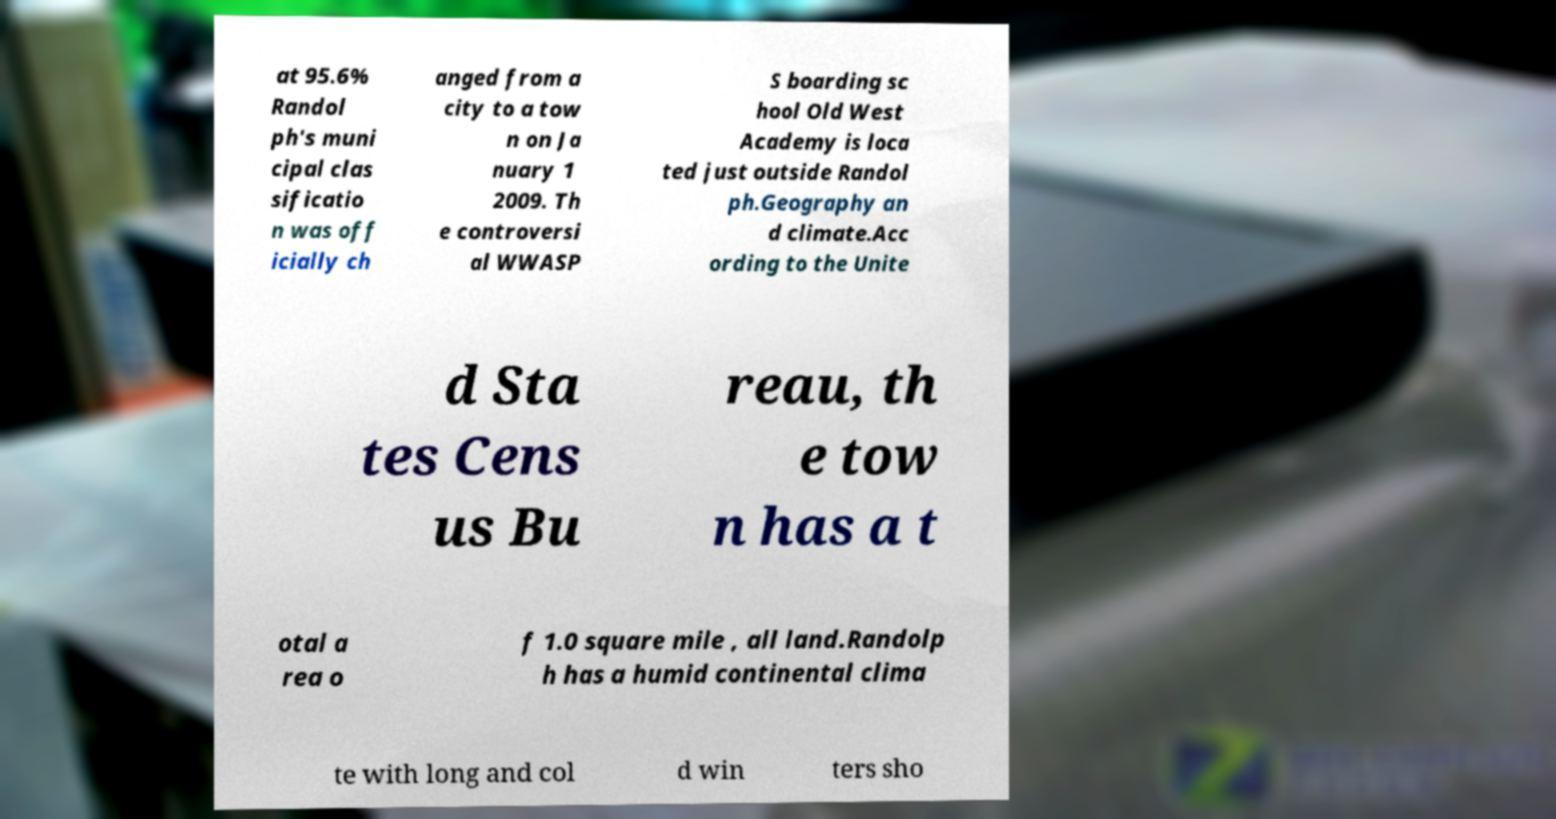I need the written content from this picture converted into text. Can you do that? at 95.6% Randol ph's muni cipal clas sificatio n was off icially ch anged from a city to a tow n on Ja nuary 1 2009. Th e controversi al WWASP S boarding sc hool Old West Academy is loca ted just outside Randol ph.Geography an d climate.Acc ording to the Unite d Sta tes Cens us Bu reau, th e tow n has a t otal a rea o f 1.0 square mile , all land.Randolp h has a humid continental clima te with long and col d win ters sho 